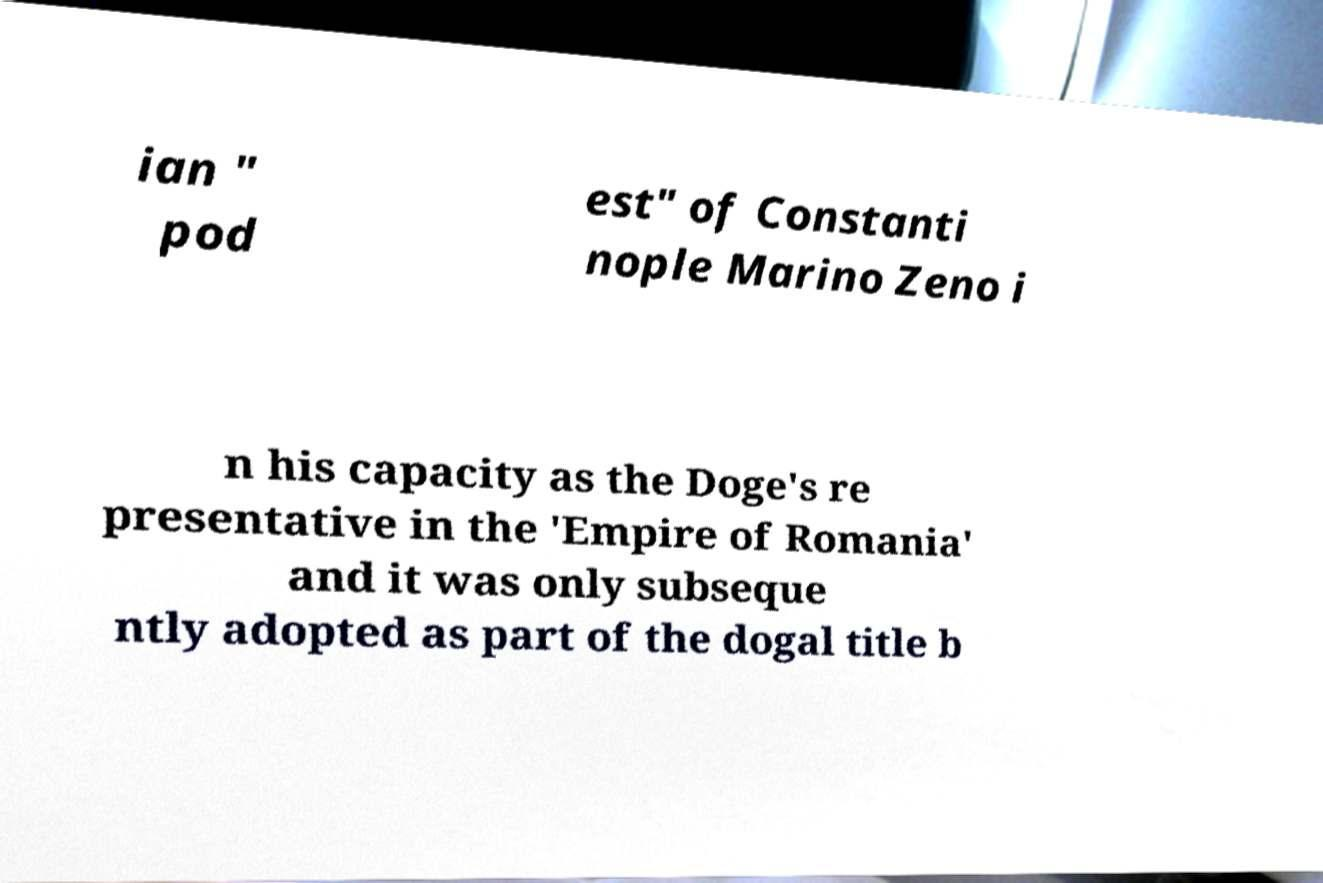Could you assist in decoding the text presented in this image and type it out clearly? ian " pod est" of Constanti nople Marino Zeno i n his capacity as the Doge's re presentative in the 'Empire of Romania' and it was only subseque ntly adopted as part of the dogal title b 